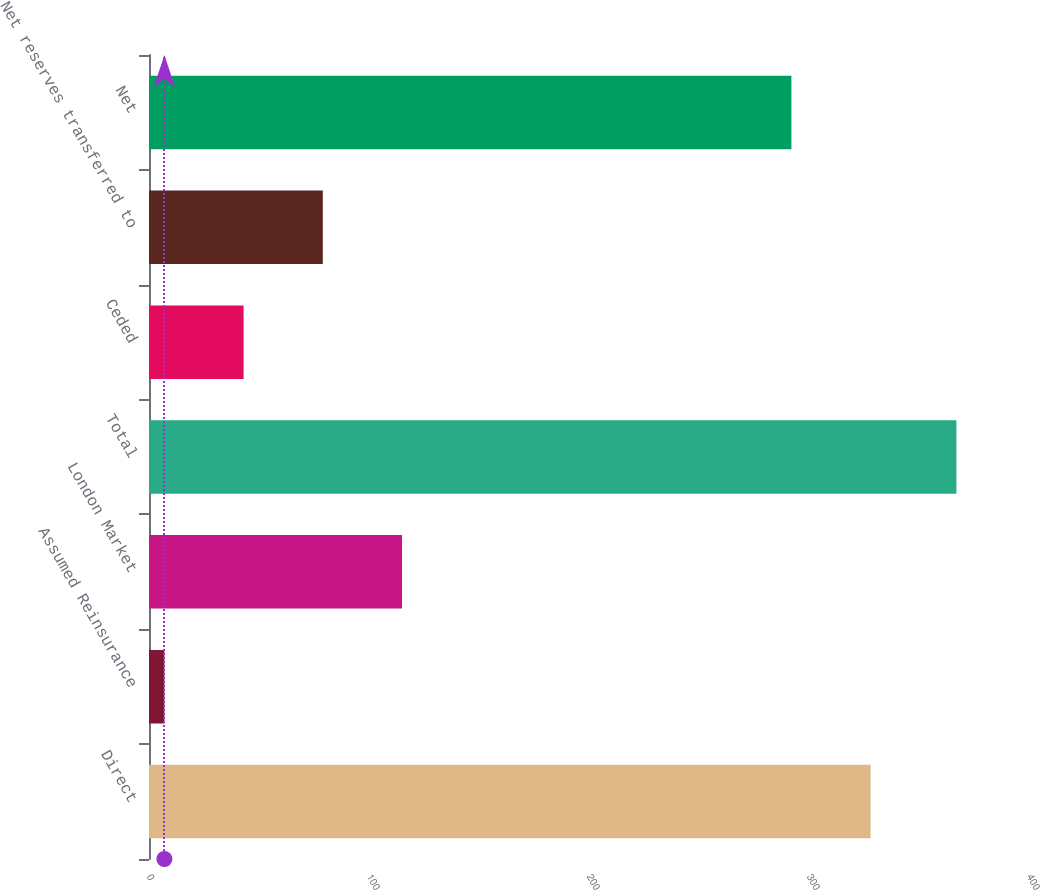<chart> <loc_0><loc_0><loc_500><loc_500><bar_chart><fcel>Direct<fcel>Assumed Reinsurance<fcel>London Market<fcel>Total<fcel>Ceded<fcel>Net reserves transferred to<fcel>Net<nl><fcel>328<fcel>7<fcel>115<fcel>367<fcel>43<fcel>79<fcel>292<nl></chart> 